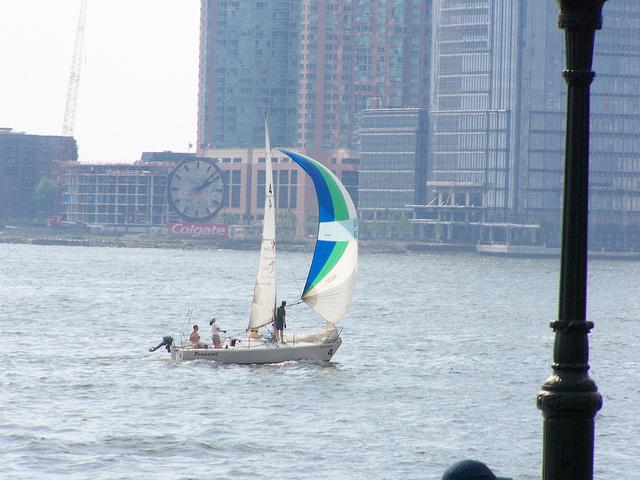What period of the day is shown here? afternoon 